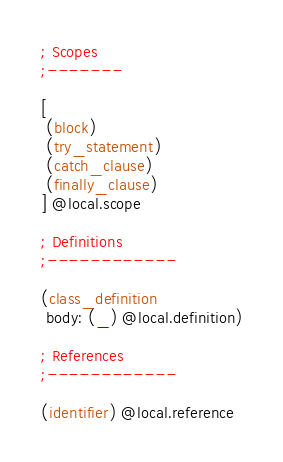Convert code to text. <code><loc_0><loc_0><loc_500><loc_500><_Scheme_>; Scopes
;-------

[
 (block)
 (try_statement)
 (catch_clause)
 (finally_clause)
] @local.scope

; Definitions
;------------

(class_definition
 body: (_) @local.definition)

; References
;------------

(identifier) @local.reference
</code> 